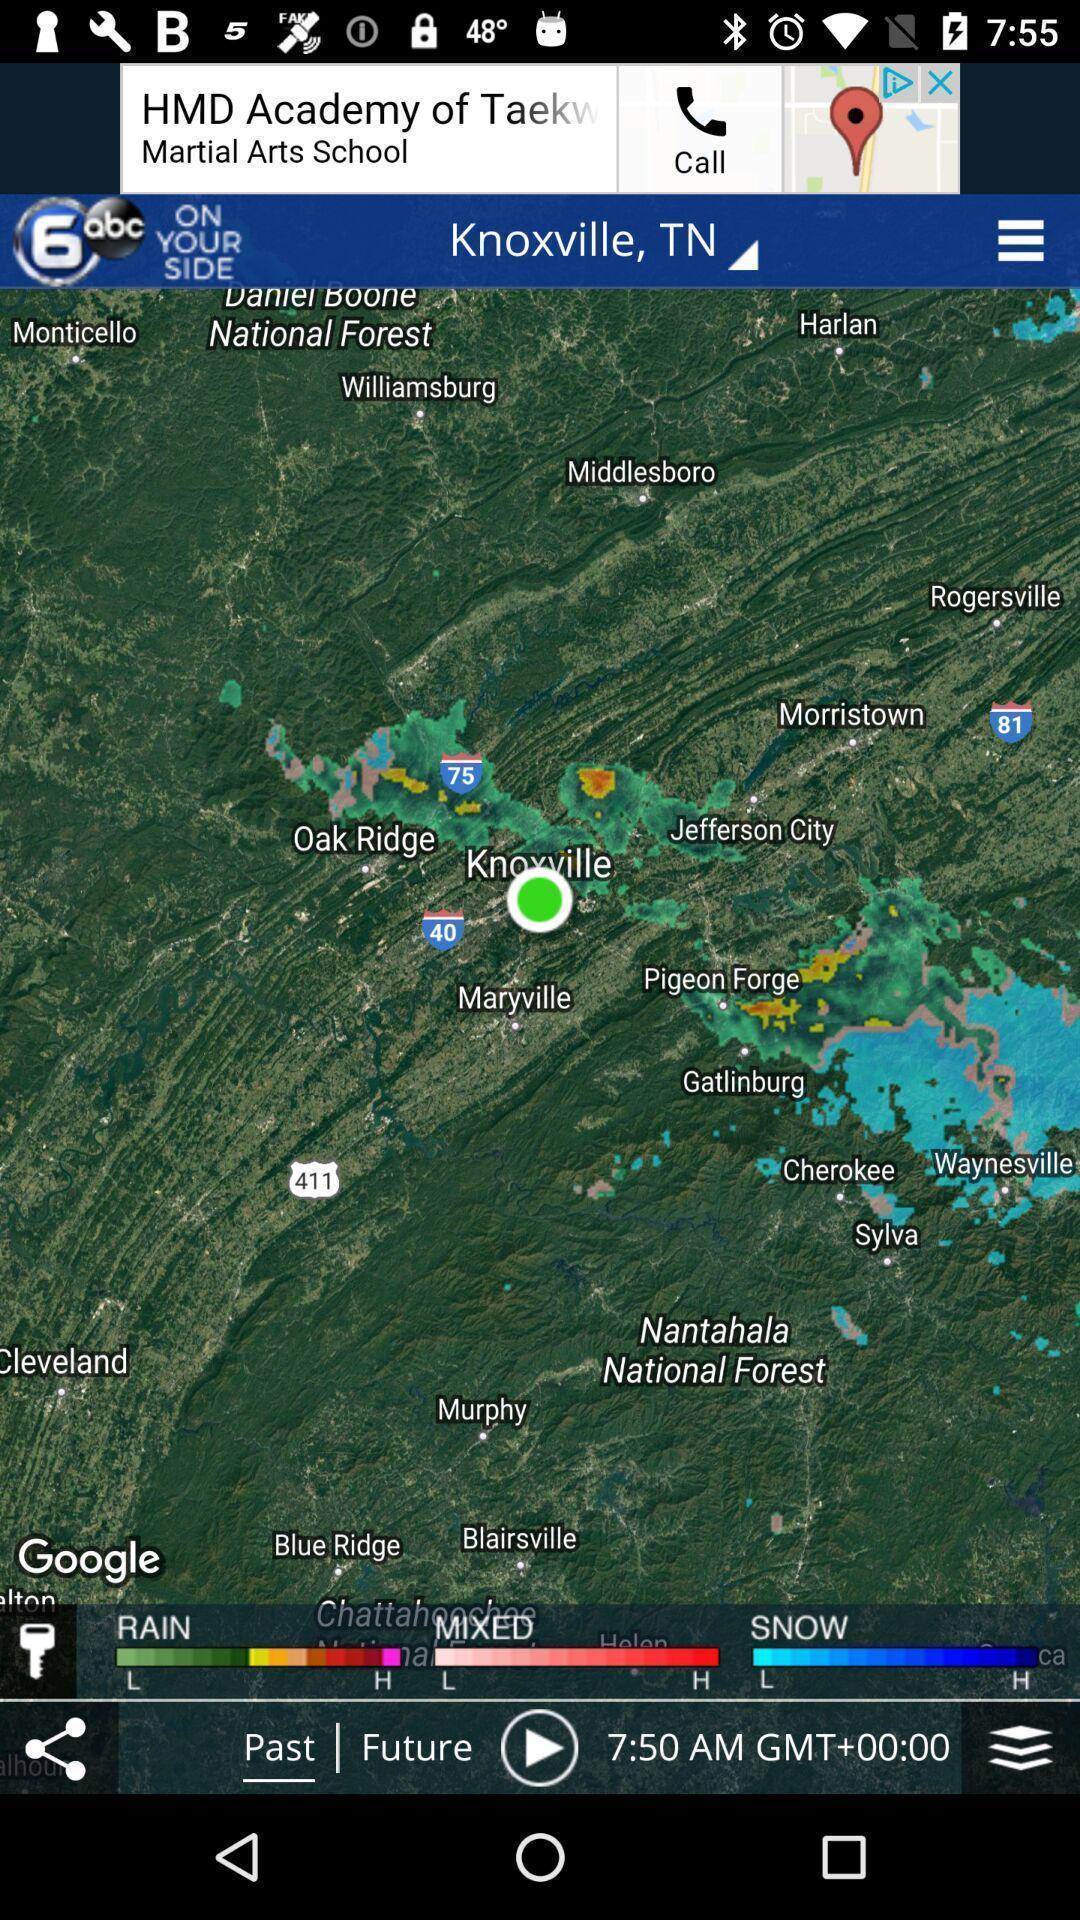Summarize the main components in this picture. Page displaying map. 